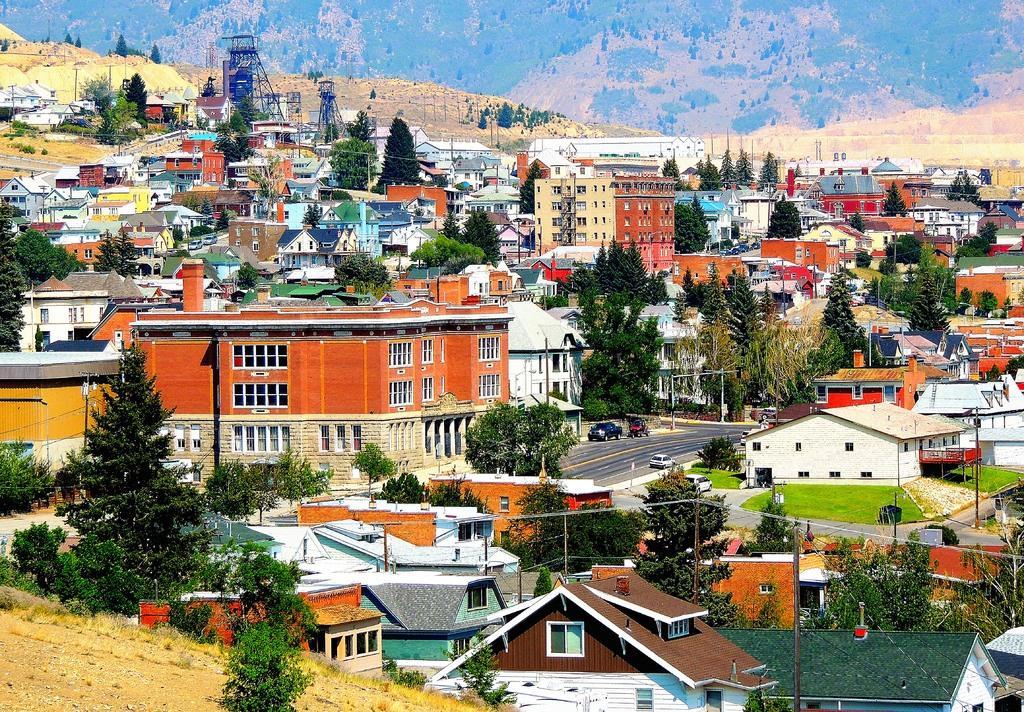Please provide a concise description of this image. It is the picture of a beautiful city there are plenty of houses, buildings, trees and roads and many more things in the city and in the background there is a mountain. 